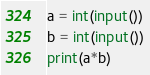Convert code to text. <code><loc_0><loc_0><loc_500><loc_500><_Python_>a = int(input())
b = int(input())
print(a*b)</code> 